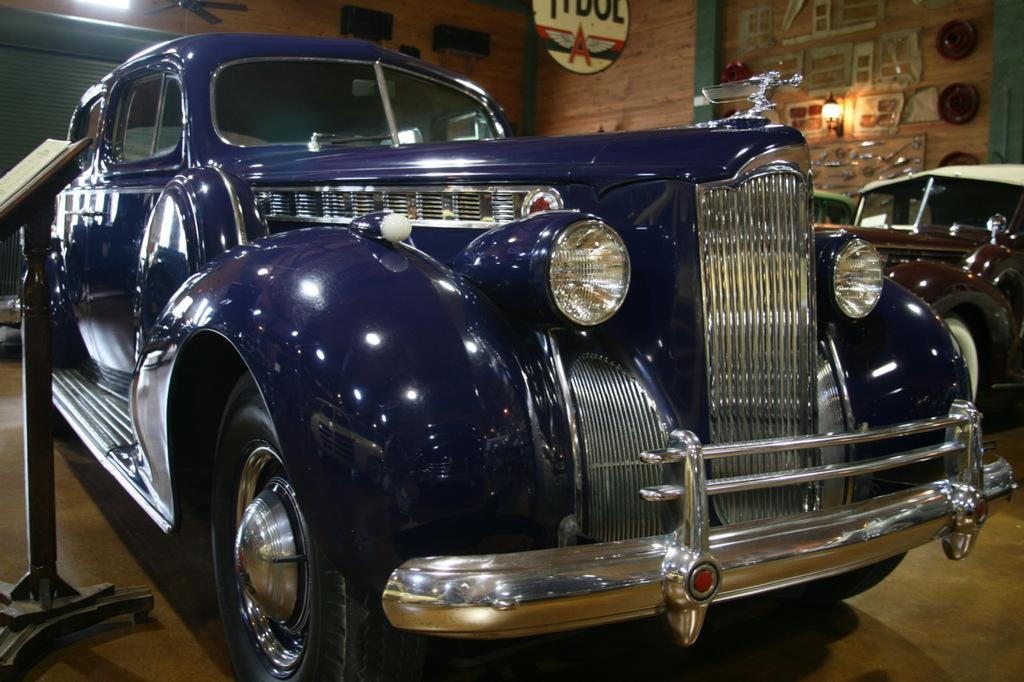Describe this image in one or two sentences. In this image there are cars, in the background there is a wooden wall, on that wall there are tool. 